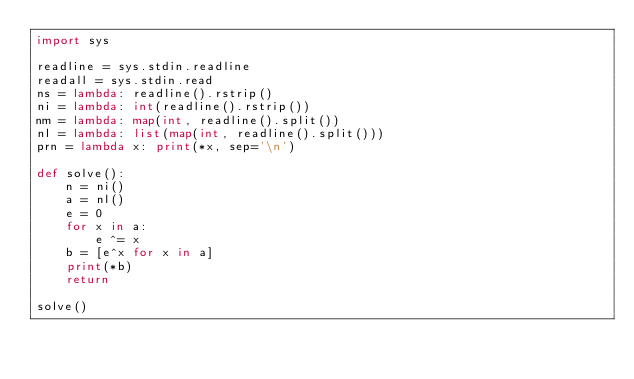Convert code to text. <code><loc_0><loc_0><loc_500><loc_500><_Python_>import sys

readline = sys.stdin.readline
readall = sys.stdin.read
ns = lambda: readline().rstrip()
ni = lambda: int(readline().rstrip())
nm = lambda: map(int, readline().split())
nl = lambda: list(map(int, readline().split()))
prn = lambda x: print(*x, sep='\n')

def solve():
    n = ni()
    a = nl()
    e = 0
    for x in a:
        e ^= x
    b = [e^x for x in a]
    print(*b)
    return

solve()
</code> 